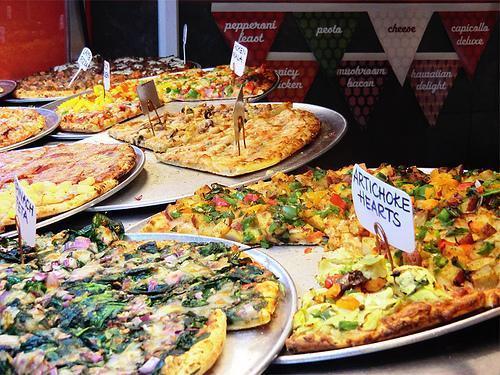How many pizzas are shown in the picture?
Give a very brief answer. 7. How many of the pizzas have green vegetables?
Give a very brief answer. 3. 